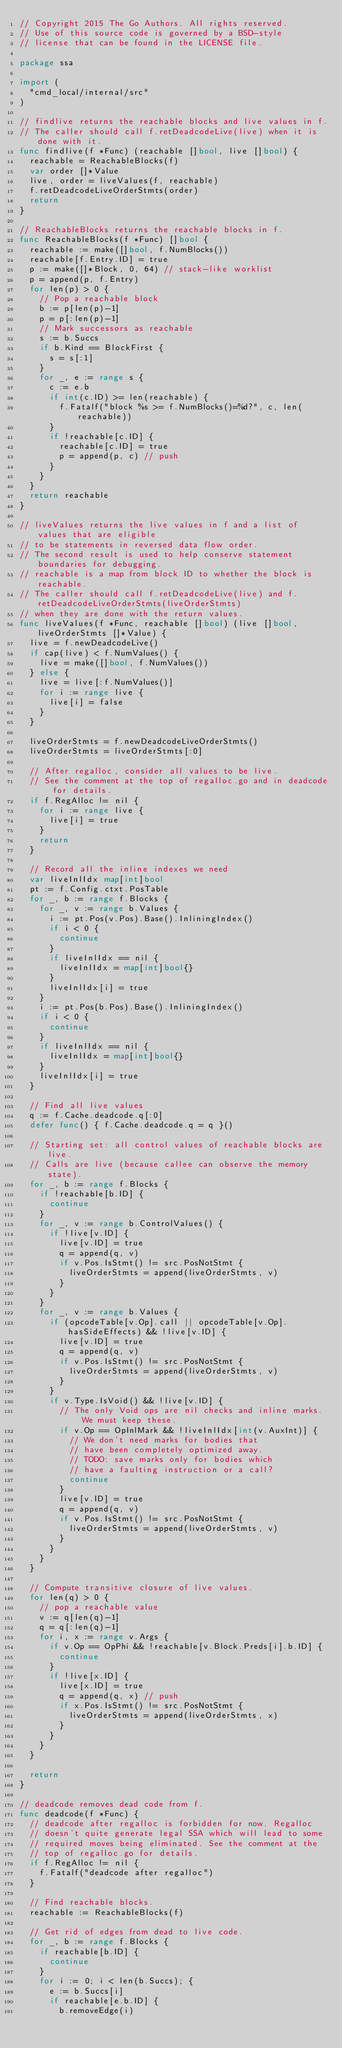<code> <loc_0><loc_0><loc_500><loc_500><_Go_>// Copyright 2015 The Go Authors. All rights reserved.
// Use of this source code is governed by a BSD-style
// license that can be found in the LICENSE file.

package ssa

import (
	"cmd_local/internal/src"
)

// findlive returns the reachable blocks and live values in f.
// The caller should call f.retDeadcodeLive(live) when it is done with it.
func findlive(f *Func) (reachable []bool, live []bool) {
	reachable = ReachableBlocks(f)
	var order []*Value
	live, order = liveValues(f, reachable)
	f.retDeadcodeLiveOrderStmts(order)
	return
}

// ReachableBlocks returns the reachable blocks in f.
func ReachableBlocks(f *Func) []bool {
	reachable := make([]bool, f.NumBlocks())
	reachable[f.Entry.ID] = true
	p := make([]*Block, 0, 64) // stack-like worklist
	p = append(p, f.Entry)
	for len(p) > 0 {
		// Pop a reachable block
		b := p[len(p)-1]
		p = p[:len(p)-1]
		// Mark successors as reachable
		s := b.Succs
		if b.Kind == BlockFirst {
			s = s[:1]
		}
		for _, e := range s {
			c := e.b
			if int(c.ID) >= len(reachable) {
				f.Fatalf("block %s >= f.NumBlocks()=%d?", c, len(reachable))
			}
			if !reachable[c.ID] {
				reachable[c.ID] = true
				p = append(p, c) // push
			}
		}
	}
	return reachable
}

// liveValues returns the live values in f and a list of values that are eligible
// to be statements in reversed data flow order.
// The second result is used to help conserve statement boundaries for debugging.
// reachable is a map from block ID to whether the block is reachable.
// The caller should call f.retDeadcodeLive(live) and f.retDeadcodeLiveOrderStmts(liveOrderStmts)
// when they are done with the return values.
func liveValues(f *Func, reachable []bool) (live []bool, liveOrderStmts []*Value) {
	live = f.newDeadcodeLive()
	if cap(live) < f.NumValues() {
		live = make([]bool, f.NumValues())
	} else {
		live = live[:f.NumValues()]
		for i := range live {
			live[i] = false
		}
	}

	liveOrderStmts = f.newDeadcodeLiveOrderStmts()
	liveOrderStmts = liveOrderStmts[:0]

	// After regalloc, consider all values to be live.
	// See the comment at the top of regalloc.go and in deadcode for details.
	if f.RegAlloc != nil {
		for i := range live {
			live[i] = true
		}
		return
	}

	// Record all the inline indexes we need
	var liveInlIdx map[int]bool
	pt := f.Config.ctxt.PosTable
	for _, b := range f.Blocks {
		for _, v := range b.Values {
			i := pt.Pos(v.Pos).Base().InliningIndex()
			if i < 0 {
				continue
			}
			if liveInlIdx == nil {
				liveInlIdx = map[int]bool{}
			}
			liveInlIdx[i] = true
		}
		i := pt.Pos(b.Pos).Base().InliningIndex()
		if i < 0 {
			continue
		}
		if liveInlIdx == nil {
			liveInlIdx = map[int]bool{}
		}
		liveInlIdx[i] = true
	}

	// Find all live values
	q := f.Cache.deadcode.q[:0]
	defer func() { f.Cache.deadcode.q = q }()

	// Starting set: all control values of reachable blocks are live.
	// Calls are live (because callee can observe the memory state).
	for _, b := range f.Blocks {
		if !reachable[b.ID] {
			continue
		}
		for _, v := range b.ControlValues() {
			if !live[v.ID] {
				live[v.ID] = true
				q = append(q, v)
				if v.Pos.IsStmt() != src.PosNotStmt {
					liveOrderStmts = append(liveOrderStmts, v)
				}
			}
		}
		for _, v := range b.Values {
			if (opcodeTable[v.Op].call || opcodeTable[v.Op].hasSideEffects) && !live[v.ID] {
				live[v.ID] = true
				q = append(q, v)
				if v.Pos.IsStmt() != src.PosNotStmt {
					liveOrderStmts = append(liveOrderStmts, v)
				}
			}
			if v.Type.IsVoid() && !live[v.ID] {
				// The only Void ops are nil checks and inline marks.  We must keep these.
				if v.Op == OpInlMark && !liveInlIdx[int(v.AuxInt)] {
					// We don't need marks for bodies that
					// have been completely optimized away.
					// TODO: save marks only for bodies which
					// have a faulting instruction or a call?
					continue
				}
				live[v.ID] = true
				q = append(q, v)
				if v.Pos.IsStmt() != src.PosNotStmt {
					liveOrderStmts = append(liveOrderStmts, v)
				}
			}
		}
	}

	// Compute transitive closure of live values.
	for len(q) > 0 {
		// pop a reachable value
		v := q[len(q)-1]
		q = q[:len(q)-1]
		for i, x := range v.Args {
			if v.Op == OpPhi && !reachable[v.Block.Preds[i].b.ID] {
				continue
			}
			if !live[x.ID] {
				live[x.ID] = true
				q = append(q, x) // push
				if x.Pos.IsStmt() != src.PosNotStmt {
					liveOrderStmts = append(liveOrderStmts, x)
				}
			}
		}
	}

	return
}

// deadcode removes dead code from f.
func deadcode(f *Func) {
	// deadcode after regalloc is forbidden for now. Regalloc
	// doesn't quite generate legal SSA which will lead to some
	// required moves being eliminated. See the comment at the
	// top of regalloc.go for details.
	if f.RegAlloc != nil {
		f.Fatalf("deadcode after regalloc")
	}

	// Find reachable blocks.
	reachable := ReachableBlocks(f)

	// Get rid of edges from dead to live code.
	for _, b := range f.Blocks {
		if reachable[b.ID] {
			continue
		}
		for i := 0; i < len(b.Succs); {
			e := b.Succs[i]
			if reachable[e.b.ID] {
				b.removeEdge(i)</code> 